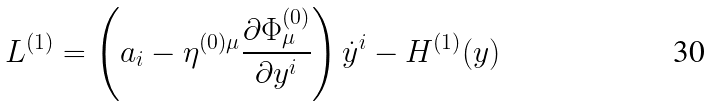Convert formula to latex. <formula><loc_0><loc_0><loc_500><loc_500>L ^ { ( 1 ) } = \left ( a _ { i } - \eta ^ { ( 0 ) \mu } \frac { \partial \Phi ^ { ( 0 ) } _ { \mu } } { \partial y ^ { i } } \right ) { \dot { y } } ^ { i } - H ^ { ( 1 ) } ( y )</formula> 